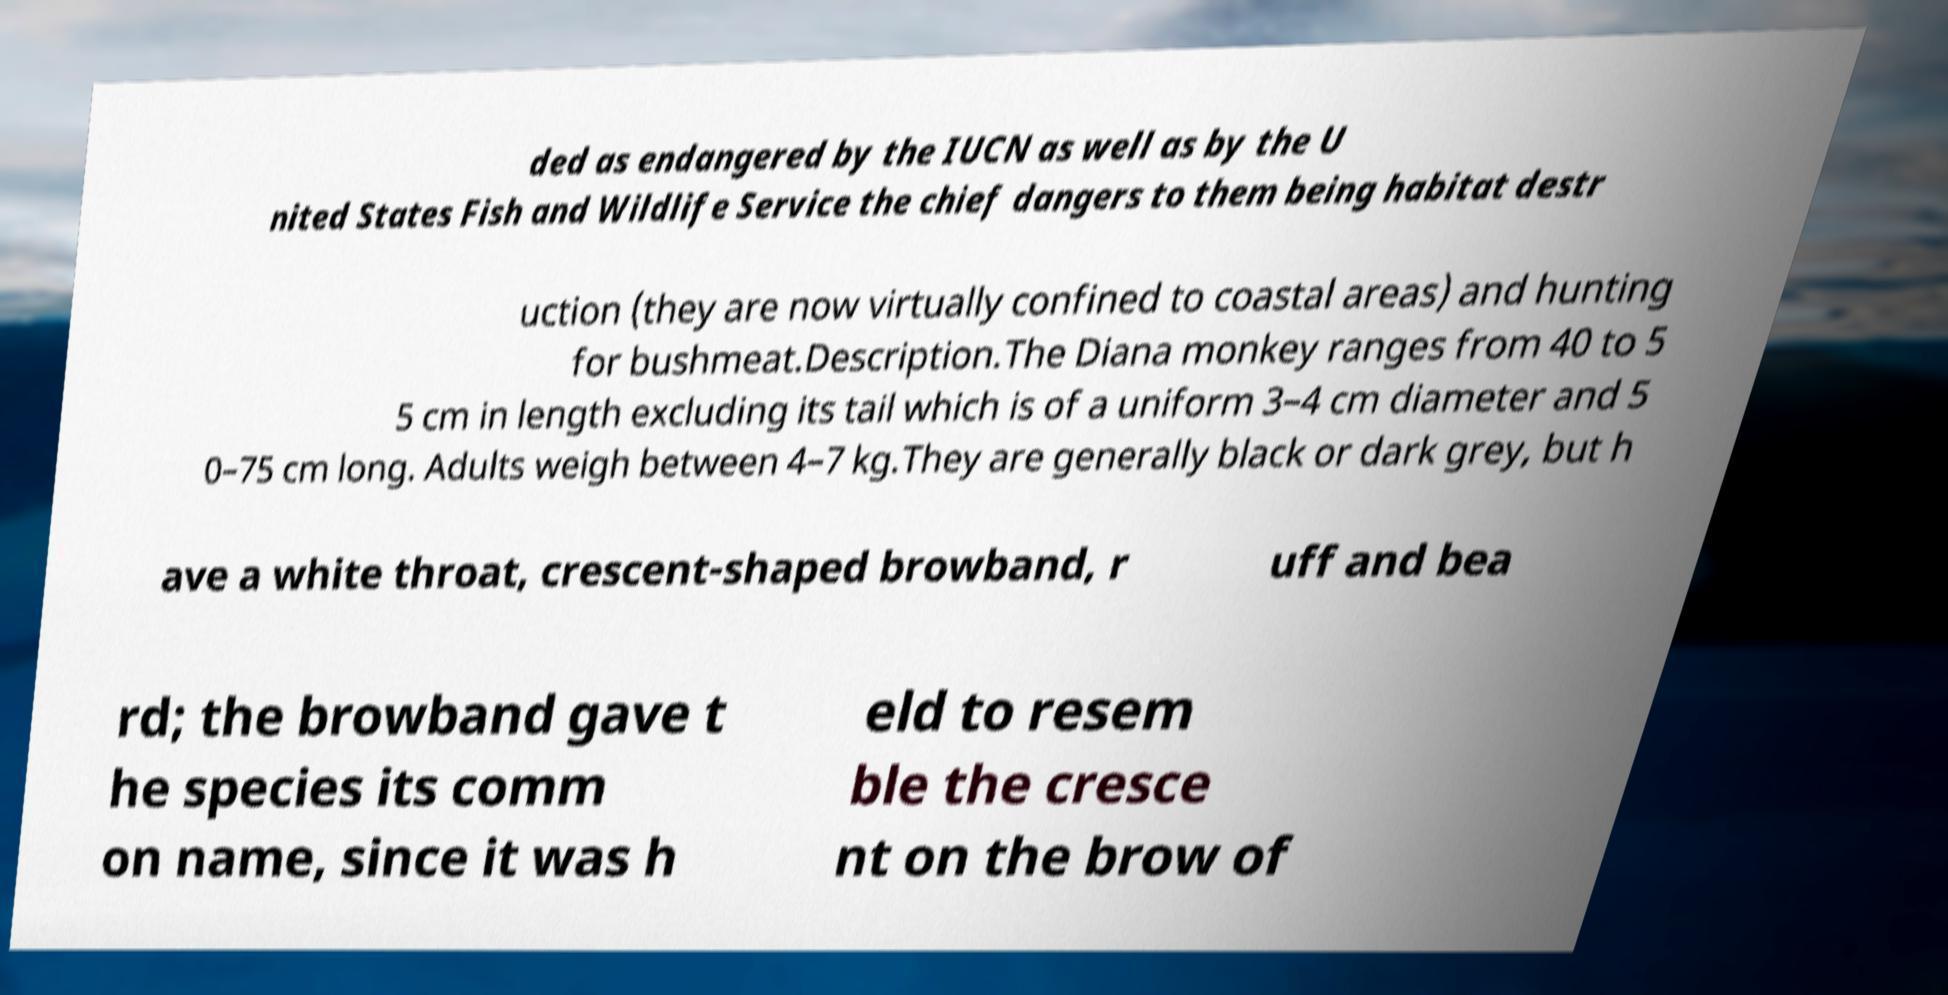Please identify and transcribe the text found in this image. ded as endangered by the IUCN as well as by the U nited States Fish and Wildlife Service the chief dangers to them being habitat destr uction (they are now virtually confined to coastal areas) and hunting for bushmeat.Description.The Diana monkey ranges from 40 to 5 5 cm in length excluding its tail which is of a uniform 3–4 cm diameter and 5 0–75 cm long. Adults weigh between 4–7 kg.They are generally black or dark grey, but h ave a white throat, crescent-shaped browband, r uff and bea rd; the browband gave t he species its comm on name, since it was h eld to resem ble the cresce nt on the brow of 